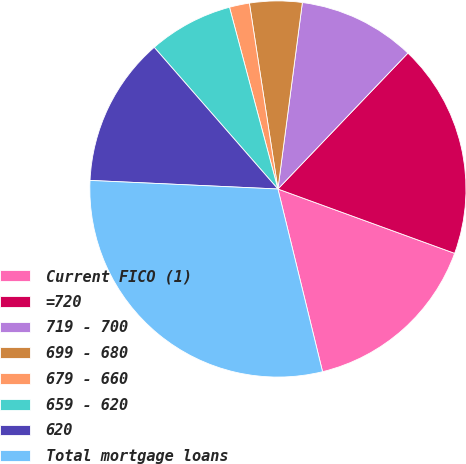<chart> <loc_0><loc_0><loc_500><loc_500><pie_chart><fcel>Current FICO (1)<fcel>=720<fcel>719 - 700<fcel>699 - 680<fcel>679 - 660<fcel>659 - 620<fcel>620<fcel>Total mortgage loans<nl><fcel>15.63%<fcel>18.41%<fcel>10.07%<fcel>4.5%<fcel>1.72%<fcel>7.28%<fcel>12.85%<fcel>29.54%<nl></chart> 